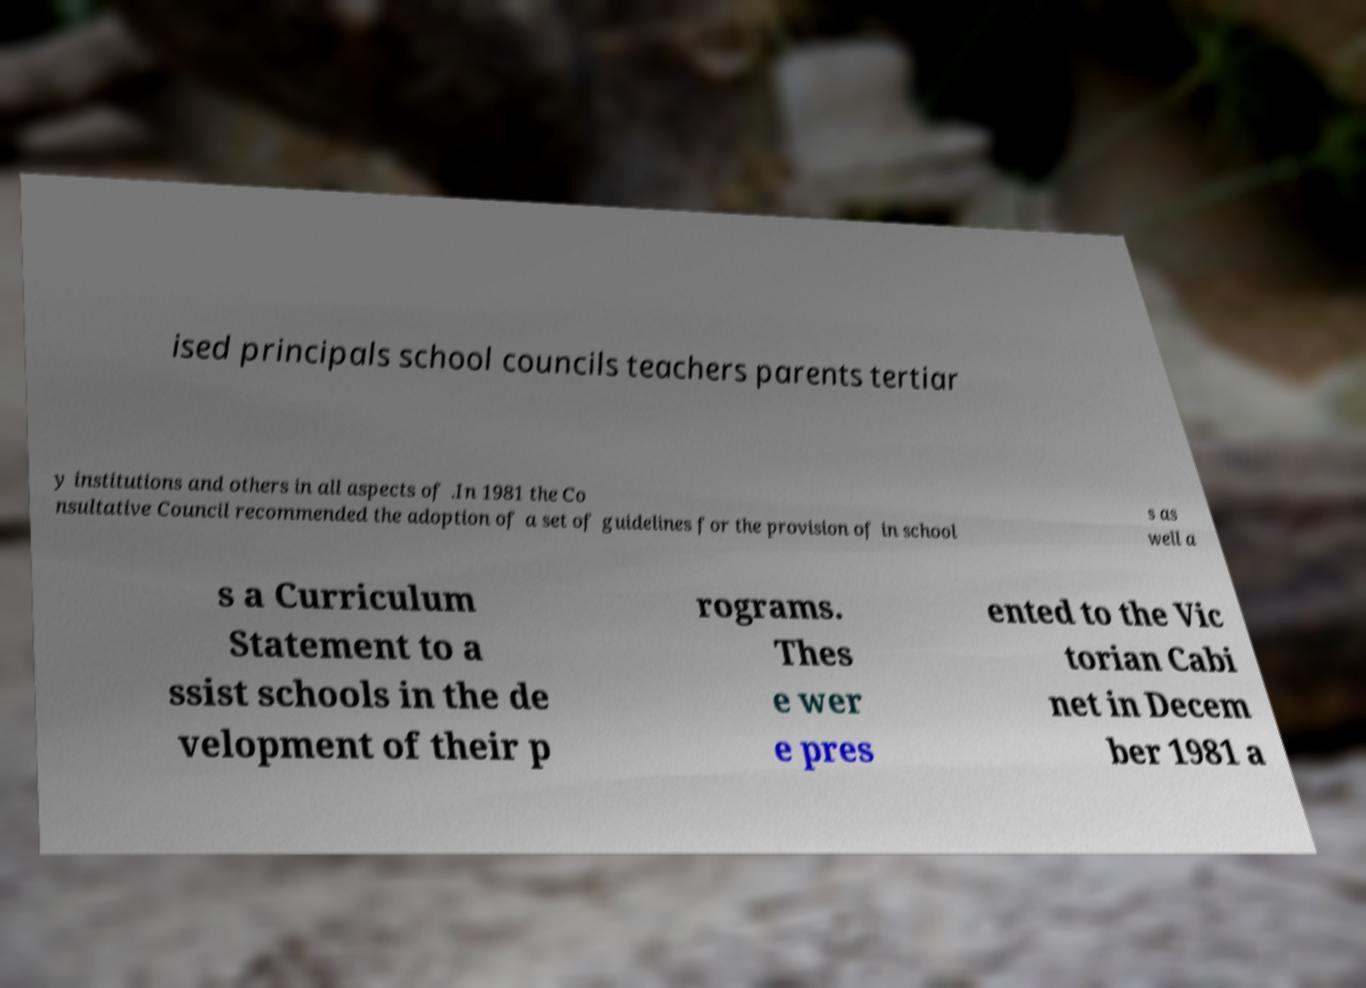What messages or text are displayed in this image? I need them in a readable, typed format. ised principals school councils teachers parents tertiar y institutions and others in all aspects of .In 1981 the Co nsultative Council recommended the adoption of a set of guidelines for the provision of in school s as well a s a Curriculum Statement to a ssist schools in the de velopment of their p rograms. Thes e wer e pres ented to the Vic torian Cabi net in Decem ber 1981 a 